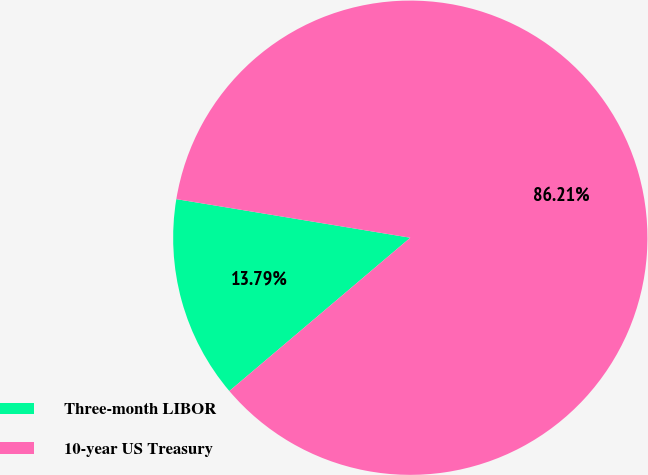<chart> <loc_0><loc_0><loc_500><loc_500><pie_chart><fcel>Three-month LIBOR<fcel>10-year US Treasury<nl><fcel>13.79%<fcel>86.21%<nl></chart> 